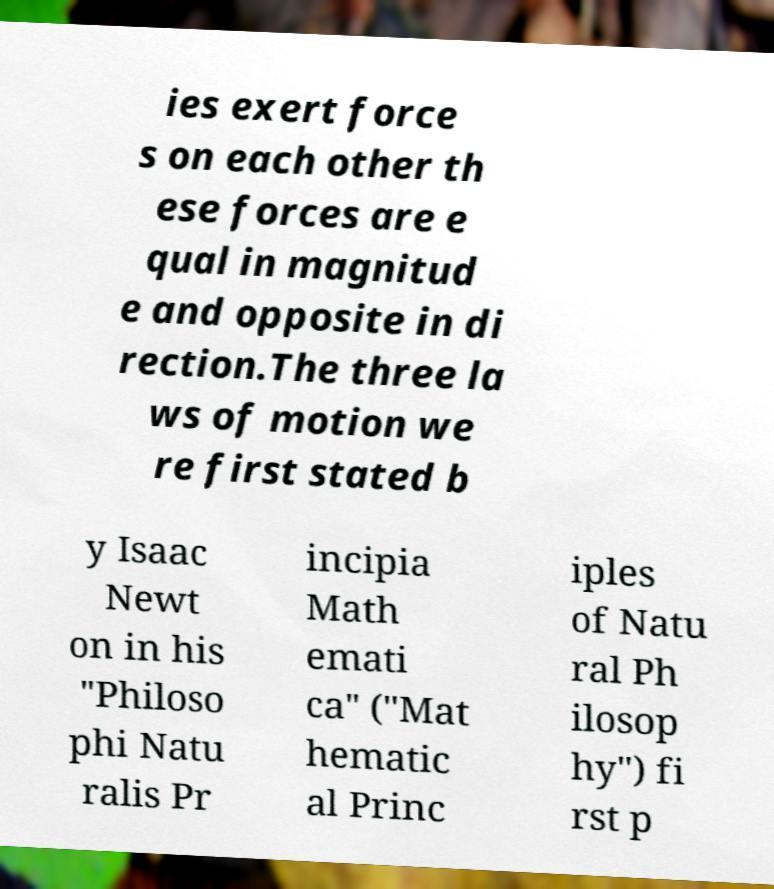Can you read and provide the text displayed in the image?This photo seems to have some interesting text. Can you extract and type it out for me? ies exert force s on each other th ese forces are e qual in magnitud e and opposite in di rection.The three la ws of motion we re first stated b y Isaac Newt on in his "Philoso phi Natu ralis Pr incipia Math emati ca" ("Mat hematic al Princ iples of Natu ral Ph ilosop hy") fi rst p 